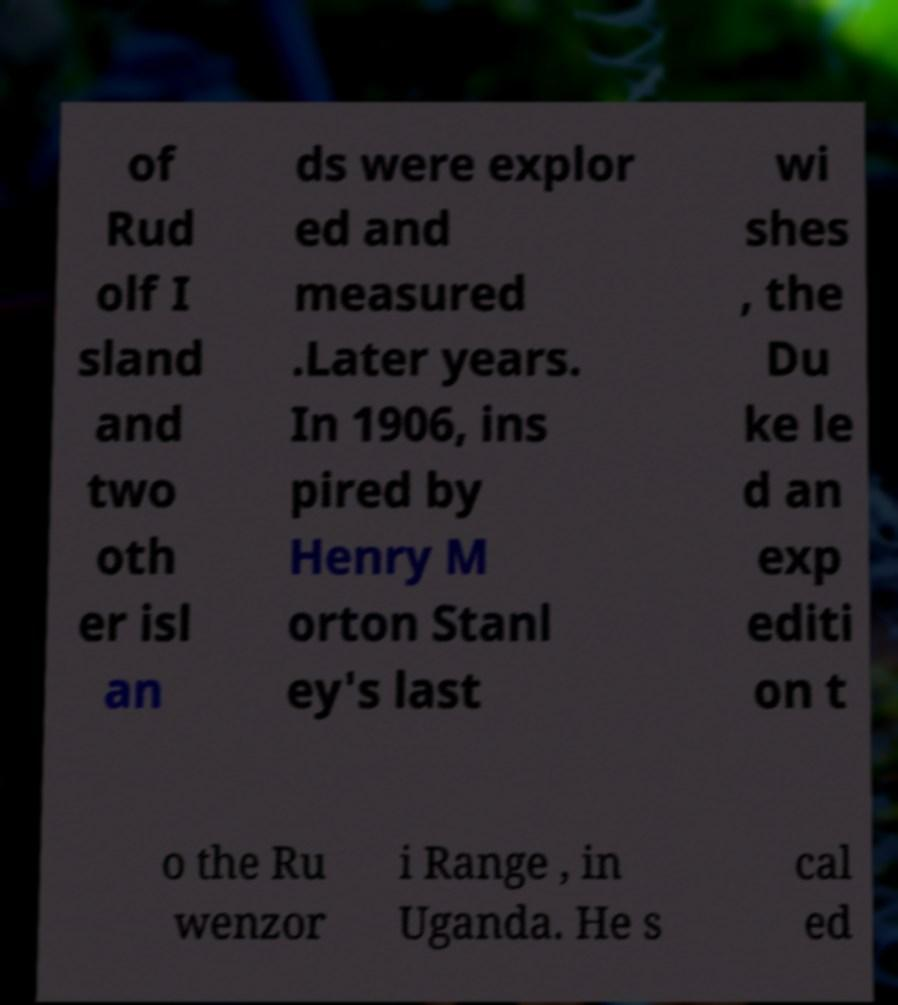Can you accurately transcribe the text from the provided image for me? of Rud olf I sland and two oth er isl an ds were explor ed and measured .Later years. In 1906, ins pired by Henry M orton Stanl ey's last wi shes , the Du ke le d an exp editi on t o the Ru wenzor i Range , in Uganda. He s cal ed 